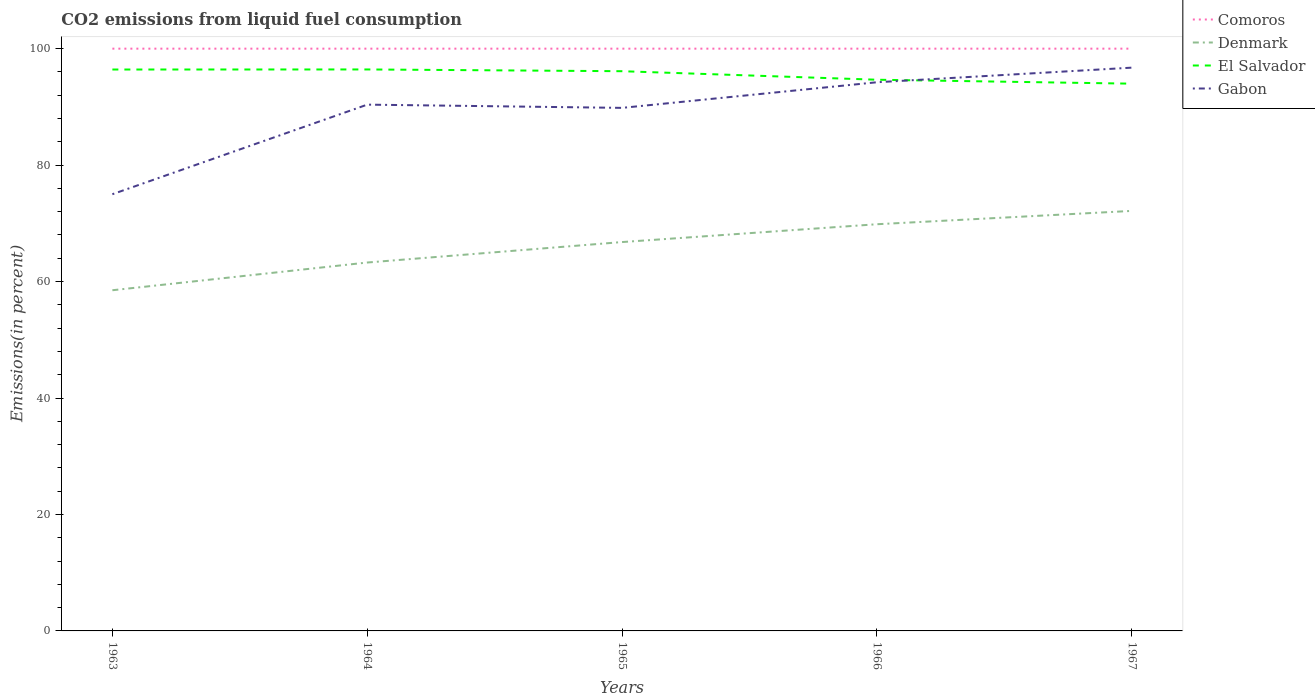How many different coloured lines are there?
Provide a succinct answer. 4. Is the number of lines equal to the number of legend labels?
Your response must be concise. Yes. Across all years, what is the maximum total CO2 emitted in Denmark?
Make the answer very short. 58.51. What is the total total CO2 emitted in El Salvador in the graph?
Offer a very short reply. 0.68. What is the difference between the highest and the second highest total CO2 emitted in El Salvador?
Provide a short and direct response. 2.44. What is the difference between the highest and the lowest total CO2 emitted in Denmark?
Ensure brevity in your answer.  3. Is the total CO2 emitted in Gabon strictly greater than the total CO2 emitted in Comoros over the years?
Your response must be concise. Yes. How many lines are there?
Offer a terse response. 4. How many legend labels are there?
Your response must be concise. 4. How are the legend labels stacked?
Provide a succinct answer. Vertical. What is the title of the graph?
Keep it short and to the point. CO2 emissions from liquid fuel consumption. What is the label or title of the X-axis?
Your response must be concise. Years. What is the label or title of the Y-axis?
Offer a terse response. Emissions(in percent). What is the Emissions(in percent) of Denmark in 1963?
Offer a terse response. 58.51. What is the Emissions(in percent) of El Salvador in 1963?
Your answer should be compact. 96.42. What is the Emissions(in percent) in Gabon in 1963?
Ensure brevity in your answer.  75. What is the Emissions(in percent) in Denmark in 1964?
Provide a short and direct response. 63.27. What is the Emissions(in percent) in El Salvador in 1964?
Offer a terse response. 96.43. What is the Emissions(in percent) of Gabon in 1964?
Make the answer very short. 90.38. What is the Emissions(in percent) of Comoros in 1965?
Make the answer very short. 100. What is the Emissions(in percent) in Denmark in 1965?
Provide a short and direct response. 66.79. What is the Emissions(in percent) of El Salvador in 1965?
Make the answer very short. 96.13. What is the Emissions(in percent) in Gabon in 1965?
Keep it short and to the point. 89.83. What is the Emissions(in percent) in Comoros in 1966?
Your answer should be very brief. 100. What is the Emissions(in percent) in Denmark in 1966?
Offer a very short reply. 69.85. What is the Emissions(in percent) of El Salvador in 1966?
Provide a succinct answer. 94.66. What is the Emissions(in percent) in Gabon in 1966?
Offer a very short reply. 94.23. What is the Emissions(in percent) in Denmark in 1967?
Ensure brevity in your answer.  72.14. What is the Emissions(in percent) in El Salvador in 1967?
Keep it short and to the point. 93.99. What is the Emissions(in percent) in Gabon in 1967?
Your answer should be very brief. 96.74. Across all years, what is the maximum Emissions(in percent) in Denmark?
Provide a succinct answer. 72.14. Across all years, what is the maximum Emissions(in percent) in El Salvador?
Keep it short and to the point. 96.43. Across all years, what is the maximum Emissions(in percent) of Gabon?
Your answer should be very brief. 96.74. Across all years, what is the minimum Emissions(in percent) of Denmark?
Offer a terse response. 58.51. Across all years, what is the minimum Emissions(in percent) of El Salvador?
Keep it short and to the point. 93.99. Across all years, what is the minimum Emissions(in percent) in Gabon?
Ensure brevity in your answer.  75. What is the total Emissions(in percent) of Comoros in the graph?
Your answer should be compact. 500. What is the total Emissions(in percent) in Denmark in the graph?
Provide a short and direct response. 330.55. What is the total Emissions(in percent) in El Salvador in the graph?
Offer a terse response. 477.62. What is the total Emissions(in percent) in Gabon in the graph?
Offer a very short reply. 446.19. What is the difference between the Emissions(in percent) in Denmark in 1963 and that in 1964?
Offer a very short reply. -4.76. What is the difference between the Emissions(in percent) in El Salvador in 1963 and that in 1964?
Provide a succinct answer. -0.01. What is the difference between the Emissions(in percent) in Gabon in 1963 and that in 1964?
Your answer should be compact. -15.38. What is the difference between the Emissions(in percent) of Comoros in 1963 and that in 1965?
Offer a terse response. 0. What is the difference between the Emissions(in percent) in Denmark in 1963 and that in 1965?
Your response must be concise. -8.28. What is the difference between the Emissions(in percent) in El Salvador in 1963 and that in 1965?
Give a very brief answer. 0.29. What is the difference between the Emissions(in percent) in Gabon in 1963 and that in 1965?
Offer a terse response. -14.83. What is the difference between the Emissions(in percent) in Denmark in 1963 and that in 1966?
Your answer should be compact. -11.34. What is the difference between the Emissions(in percent) of El Salvador in 1963 and that in 1966?
Offer a very short reply. 1.75. What is the difference between the Emissions(in percent) of Gabon in 1963 and that in 1966?
Give a very brief answer. -19.23. What is the difference between the Emissions(in percent) of Comoros in 1963 and that in 1967?
Ensure brevity in your answer.  0. What is the difference between the Emissions(in percent) in Denmark in 1963 and that in 1967?
Your answer should be very brief. -13.63. What is the difference between the Emissions(in percent) of El Salvador in 1963 and that in 1967?
Offer a very short reply. 2.43. What is the difference between the Emissions(in percent) in Gabon in 1963 and that in 1967?
Keep it short and to the point. -21.74. What is the difference between the Emissions(in percent) in Comoros in 1964 and that in 1965?
Provide a short and direct response. 0. What is the difference between the Emissions(in percent) of Denmark in 1964 and that in 1965?
Your response must be concise. -3.51. What is the difference between the Emissions(in percent) in El Salvador in 1964 and that in 1965?
Your answer should be very brief. 0.3. What is the difference between the Emissions(in percent) in Gabon in 1964 and that in 1965?
Your answer should be compact. 0.55. What is the difference between the Emissions(in percent) of Denmark in 1964 and that in 1966?
Offer a terse response. -6.58. What is the difference between the Emissions(in percent) in El Salvador in 1964 and that in 1966?
Your response must be concise. 1.77. What is the difference between the Emissions(in percent) in Gabon in 1964 and that in 1966?
Offer a very short reply. -3.85. What is the difference between the Emissions(in percent) of Denmark in 1964 and that in 1967?
Ensure brevity in your answer.  -8.87. What is the difference between the Emissions(in percent) in El Salvador in 1964 and that in 1967?
Your response must be concise. 2.44. What is the difference between the Emissions(in percent) of Gabon in 1964 and that in 1967?
Your answer should be very brief. -6.35. What is the difference between the Emissions(in percent) in Comoros in 1965 and that in 1966?
Your answer should be very brief. 0. What is the difference between the Emissions(in percent) in Denmark in 1965 and that in 1966?
Your answer should be compact. -3.06. What is the difference between the Emissions(in percent) of El Salvador in 1965 and that in 1966?
Offer a very short reply. 1.46. What is the difference between the Emissions(in percent) of Gabon in 1965 and that in 1966?
Offer a terse response. -4.4. What is the difference between the Emissions(in percent) of Denmark in 1965 and that in 1967?
Provide a short and direct response. -5.35. What is the difference between the Emissions(in percent) of El Salvador in 1965 and that in 1967?
Offer a terse response. 2.14. What is the difference between the Emissions(in percent) in Gabon in 1965 and that in 1967?
Provide a succinct answer. -6.91. What is the difference between the Emissions(in percent) in Denmark in 1966 and that in 1967?
Keep it short and to the point. -2.29. What is the difference between the Emissions(in percent) in El Salvador in 1966 and that in 1967?
Offer a terse response. 0.68. What is the difference between the Emissions(in percent) in Gabon in 1966 and that in 1967?
Your answer should be very brief. -2.51. What is the difference between the Emissions(in percent) in Comoros in 1963 and the Emissions(in percent) in Denmark in 1964?
Offer a terse response. 36.73. What is the difference between the Emissions(in percent) of Comoros in 1963 and the Emissions(in percent) of El Salvador in 1964?
Make the answer very short. 3.57. What is the difference between the Emissions(in percent) in Comoros in 1963 and the Emissions(in percent) in Gabon in 1964?
Your answer should be compact. 9.62. What is the difference between the Emissions(in percent) of Denmark in 1963 and the Emissions(in percent) of El Salvador in 1964?
Offer a very short reply. -37.92. What is the difference between the Emissions(in percent) in Denmark in 1963 and the Emissions(in percent) in Gabon in 1964?
Your response must be concise. -31.88. What is the difference between the Emissions(in percent) in El Salvador in 1963 and the Emissions(in percent) in Gabon in 1964?
Give a very brief answer. 6.03. What is the difference between the Emissions(in percent) in Comoros in 1963 and the Emissions(in percent) in Denmark in 1965?
Offer a terse response. 33.21. What is the difference between the Emissions(in percent) in Comoros in 1963 and the Emissions(in percent) in El Salvador in 1965?
Your answer should be very brief. 3.87. What is the difference between the Emissions(in percent) of Comoros in 1963 and the Emissions(in percent) of Gabon in 1965?
Provide a succinct answer. 10.17. What is the difference between the Emissions(in percent) of Denmark in 1963 and the Emissions(in percent) of El Salvador in 1965?
Your answer should be very brief. -37.62. What is the difference between the Emissions(in percent) of Denmark in 1963 and the Emissions(in percent) of Gabon in 1965?
Make the answer very short. -31.32. What is the difference between the Emissions(in percent) in El Salvador in 1963 and the Emissions(in percent) in Gabon in 1965?
Give a very brief answer. 6.59. What is the difference between the Emissions(in percent) of Comoros in 1963 and the Emissions(in percent) of Denmark in 1966?
Your answer should be compact. 30.15. What is the difference between the Emissions(in percent) of Comoros in 1963 and the Emissions(in percent) of El Salvador in 1966?
Ensure brevity in your answer.  5.34. What is the difference between the Emissions(in percent) of Comoros in 1963 and the Emissions(in percent) of Gabon in 1966?
Ensure brevity in your answer.  5.77. What is the difference between the Emissions(in percent) of Denmark in 1963 and the Emissions(in percent) of El Salvador in 1966?
Your response must be concise. -36.15. What is the difference between the Emissions(in percent) in Denmark in 1963 and the Emissions(in percent) in Gabon in 1966?
Provide a succinct answer. -35.72. What is the difference between the Emissions(in percent) of El Salvador in 1963 and the Emissions(in percent) of Gabon in 1966?
Make the answer very short. 2.19. What is the difference between the Emissions(in percent) of Comoros in 1963 and the Emissions(in percent) of Denmark in 1967?
Your answer should be very brief. 27.86. What is the difference between the Emissions(in percent) of Comoros in 1963 and the Emissions(in percent) of El Salvador in 1967?
Provide a succinct answer. 6.01. What is the difference between the Emissions(in percent) of Comoros in 1963 and the Emissions(in percent) of Gabon in 1967?
Offer a terse response. 3.26. What is the difference between the Emissions(in percent) in Denmark in 1963 and the Emissions(in percent) in El Salvador in 1967?
Offer a terse response. -35.48. What is the difference between the Emissions(in percent) of Denmark in 1963 and the Emissions(in percent) of Gabon in 1967?
Your response must be concise. -38.23. What is the difference between the Emissions(in percent) in El Salvador in 1963 and the Emissions(in percent) in Gabon in 1967?
Your response must be concise. -0.32. What is the difference between the Emissions(in percent) in Comoros in 1964 and the Emissions(in percent) in Denmark in 1965?
Your answer should be very brief. 33.21. What is the difference between the Emissions(in percent) in Comoros in 1964 and the Emissions(in percent) in El Salvador in 1965?
Offer a very short reply. 3.87. What is the difference between the Emissions(in percent) of Comoros in 1964 and the Emissions(in percent) of Gabon in 1965?
Your answer should be very brief. 10.17. What is the difference between the Emissions(in percent) in Denmark in 1964 and the Emissions(in percent) in El Salvador in 1965?
Your answer should be very brief. -32.86. What is the difference between the Emissions(in percent) in Denmark in 1964 and the Emissions(in percent) in Gabon in 1965?
Offer a terse response. -26.56. What is the difference between the Emissions(in percent) in El Salvador in 1964 and the Emissions(in percent) in Gabon in 1965?
Ensure brevity in your answer.  6.6. What is the difference between the Emissions(in percent) in Comoros in 1964 and the Emissions(in percent) in Denmark in 1966?
Provide a succinct answer. 30.15. What is the difference between the Emissions(in percent) of Comoros in 1964 and the Emissions(in percent) of El Salvador in 1966?
Your answer should be compact. 5.34. What is the difference between the Emissions(in percent) of Comoros in 1964 and the Emissions(in percent) of Gabon in 1966?
Offer a very short reply. 5.77. What is the difference between the Emissions(in percent) of Denmark in 1964 and the Emissions(in percent) of El Salvador in 1966?
Your answer should be compact. -31.39. What is the difference between the Emissions(in percent) of Denmark in 1964 and the Emissions(in percent) of Gabon in 1966?
Offer a terse response. -30.96. What is the difference between the Emissions(in percent) of El Salvador in 1964 and the Emissions(in percent) of Gabon in 1966?
Give a very brief answer. 2.2. What is the difference between the Emissions(in percent) of Comoros in 1964 and the Emissions(in percent) of Denmark in 1967?
Give a very brief answer. 27.86. What is the difference between the Emissions(in percent) of Comoros in 1964 and the Emissions(in percent) of El Salvador in 1967?
Your answer should be compact. 6.01. What is the difference between the Emissions(in percent) of Comoros in 1964 and the Emissions(in percent) of Gabon in 1967?
Provide a succinct answer. 3.26. What is the difference between the Emissions(in percent) of Denmark in 1964 and the Emissions(in percent) of El Salvador in 1967?
Your answer should be very brief. -30.72. What is the difference between the Emissions(in percent) in Denmark in 1964 and the Emissions(in percent) in Gabon in 1967?
Your response must be concise. -33.47. What is the difference between the Emissions(in percent) of El Salvador in 1964 and the Emissions(in percent) of Gabon in 1967?
Offer a terse response. -0.31. What is the difference between the Emissions(in percent) of Comoros in 1965 and the Emissions(in percent) of Denmark in 1966?
Your response must be concise. 30.15. What is the difference between the Emissions(in percent) of Comoros in 1965 and the Emissions(in percent) of El Salvador in 1966?
Provide a succinct answer. 5.34. What is the difference between the Emissions(in percent) in Comoros in 1965 and the Emissions(in percent) in Gabon in 1966?
Your answer should be very brief. 5.77. What is the difference between the Emissions(in percent) in Denmark in 1965 and the Emissions(in percent) in El Salvador in 1966?
Your response must be concise. -27.88. What is the difference between the Emissions(in percent) of Denmark in 1965 and the Emissions(in percent) of Gabon in 1966?
Offer a terse response. -27.45. What is the difference between the Emissions(in percent) of El Salvador in 1965 and the Emissions(in percent) of Gabon in 1966?
Keep it short and to the point. 1.9. What is the difference between the Emissions(in percent) in Comoros in 1965 and the Emissions(in percent) in Denmark in 1967?
Make the answer very short. 27.86. What is the difference between the Emissions(in percent) in Comoros in 1965 and the Emissions(in percent) in El Salvador in 1967?
Your response must be concise. 6.01. What is the difference between the Emissions(in percent) in Comoros in 1965 and the Emissions(in percent) in Gabon in 1967?
Your answer should be compact. 3.26. What is the difference between the Emissions(in percent) of Denmark in 1965 and the Emissions(in percent) of El Salvador in 1967?
Provide a short and direct response. -27.2. What is the difference between the Emissions(in percent) in Denmark in 1965 and the Emissions(in percent) in Gabon in 1967?
Ensure brevity in your answer.  -29.95. What is the difference between the Emissions(in percent) of El Salvador in 1965 and the Emissions(in percent) of Gabon in 1967?
Your answer should be very brief. -0.61. What is the difference between the Emissions(in percent) of Comoros in 1966 and the Emissions(in percent) of Denmark in 1967?
Ensure brevity in your answer.  27.86. What is the difference between the Emissions(in percent) in Comoros in 1966 and the Emissions(in percent) in El Salvador in 1967?
Your answer should be compact. 6.01. What is the difference between the Emissions(in percent) of Comoros in 1966 and the Emissions(in percent) of Gabon in 1967?
Ensure brevity in your answer.  3.26. What is the difference between the Emissions(in percent) in Denmark in 1966 and the Emissions(in percent) in El Salvador in 1967?
Ensure brevity in your answer.  -24.14. What is the difference between the Emissions(in percent) of Denmark in 1966 and the Emissions(in percent) of Gabon in 1967?
Make the answer very short. -26.89. What is the difference between the Emissions(in percent) in El Salvador in 1966 and the Emissions(in percent) in Gabon in 1967?
Keep it short and to the point. -2.08. What is the average Emissions(in percent) of Comoros per year?
Provide a succinct answer. 100. What is the average Emissions(in percent) of Denmark per year?
Offer a terse response. 66.11. What is the average Emissions(in percent) in El Salvador per year?
Provide a succinct answer. 95.52. What is the average Emissions(in percent) in Gabon per year?
Provide a short and direct response. 89.24. In the year 1963, what is the difference between the Emissions(in percent) in Comoros and Emissions(in percent) in Denmark?
Your response must be concise. 41.49. In the year 1963, what is the difference between the Emissions(in percent) in Comoros and Emissions(in percent) in El Salvador?
Provide a succinct answer. 3.58. In the year 1963, what is the difference between the Emissions(in percent) of Denmark and Emissions(in percent) of El Salvador?
Make the answer very short. -37.91. In the year 1963, what is the difference between the Emissions(in percent) of Denmark and Emissions(in percent) of Gabon?
Your answer should be compact. -16.49. In the year 1963, what is the difference between the Emissions(in percent) of El Salvador and Emissions(in percent) of Gabon?
Give a very brief answer. 21.42. In the year 1964, what is the difference between the Emissions(in percent) of Comoros and Emissions(in percent) of Denmark?
Keep it short and to the point. 36.73. In the year 1964, what is the difference between the Emissions(in percent) of Comoros and Emissions(in percent) of El Salvador?
Offer a very short reply. 3.57. In the year 1964, what is the difference between the Emissions(in percent) of Comoros and Emissions(in percent) of Gabon?
Provide a short and direct response. 9.62. In the year 1964, what is the difference between the Emissions(in percent) of Denmark and Emissions(in percent) of El Salvador?
Provide a short and direct response. -33.16. In the year 1964, what is the difference between the Emissions(in percent) in Denmark and Emissions(in percent) in Gabon?
Ensure brevity in your answer.  -27.11. In the year 1964, what is the difference between the Emissions(in percent) in El Salvador and Emissions(in percent) in Gabon?
Give a very brief answer. 6.04. In the year 1965, what is the difference between the Emissions(in percent) in Comoros and Emissions(in percent) in Denmark?
Offer a very short reply. 33.21. In the year 1965, what is the difference between the Emissions(in percent) in Comoros and Emissions(in percent) in El Salvador?
Make the answer very short. 3.87. In the year 1965, what is the difference between the Emissions(in percent) of Comoros and Emissions(in percent) of Gabon?
Provide a short and direct response. 10.17. In the year 1965, what is the difference between the Emissions(in percent) in Denmark and Emissions(in percent) in El Salvador?
Your response must be concise. -29.34. In the year 1965, what is the difference between the Emissions(in percent) of Denmark and Emissions(in percent) of Gabon?
Your response must be concise. -23.05. In the year 1965, what is the difference between the Emissions(in percent) in El Salvador and Emissions(in percent) in Gabon?
Give a very brief answer. 6.3. In the year 1966, what is the difference between the Emissions(in percent) in Comoros and Emissions(in percent) in Denmark?
Your answer should be compact. 30.15. In the year 1966, what is the difference between the Emissions(in percent) of Comoros and Emissions(in percent) of El Salvador?
Ensure brevity in your answer.  5.34. In the year 1966, what is the difference between the Emissions(in percent) of Comoros and Emissions(in percent) of Gabon?
Give a very brief answer. 5.77. In the year 1966, what is the difference between the Emissions(in percent) in Denmark and Emissions(in percent) in El Salvador?
Your response must be concise. -24.82. In the year 1966, what is the difference between the Emissions(in percent) of Denmark and Emissions(in percent) of Gabon?
Provide a succinct answer. -24.38. In the year 1966, what is the difference between the Emissions(in percent) in El Salvador and Emissions(in percent) in Gabon?
Keep it short and to the point. 0.43. In the year 1967, what is the difference between the Emissions(in percent) in Comoros and Emissions(in percent) in Denmark?
Keep it short and to the point. 27.86. In the year 1967, what is the difference between the Emissions(in percent) in Comoros and Emissions(in percent) in El Salvador?
Your answer should be very brief. 6.01. In the year 1967, what is the difference between the Emissions(in percent) in Comoros and Emissions(in percent) in Gabon?
Provide a short and direct response. 3.26. In the year 1967, what is the difference between the Emissions(in percent) in Denmark and Emissions(in percent) in El Salvador?
Your response must be concise. -21.85. In the year 1967, what is the difference between the Emissions(in percent) of Denmark and Emissions(in percent) of Gabon?
Your answer should be compact. -24.6. In the year 1967, what is the difference between the Emissions(in percent) in El Salvador and Emissions(in percent) in Gabon?
Provide a succinct answer. -2.75. What is the ratio of the Emissions(in percent) of Comoros in 1963 to that in 1964?
Offer a very short reply. 1. What is the ratio of the Emissions(in percent) of Denmark in 1963 to that in 1964?
Make the answer very short. 0.92. What is the ratio of the Emissions(in percent) in Gabon in 1963 to that in 1964?
Ensure brevity in your answer.  0.83. What is the ratio of the Emissions(in percent) in Denmark in 1963 to that in 1965?
Give a very brief answer. 0.88. What is the ratio of the Emissions(in percent) in Gabon in 1963 to that in 1965?
Keep it short and to the point. 0.83. What is the ratio of the Emissions(in percent) of Denmark in 1963 to that in 1966?
Give a very brief answer. 0.84. What is the ratio of the Emissions(in percent) in El Salvador in 1963 to that in 1966?
Keep it short and to the point. 1.02. What is the ratio of the Emissions(in percent) of Gabon in 1963 to that in 1966?
Your response must be concise. 0.8. What is the ratio of the Emissions(in percent) of Comoros in 1963 to that in 1967?
Ensure brevity in your answer.  1. What is the ratio of the Emissions(in percent) in Denmark in 1963 to that in 1967?
Your answer should be compact. 0.81. What is the ratio of the Emissions(in percent) in El Salvador in 1963 to that in 1967?
Keep it short and to the point. 1.03. What is the ratio of the Emissions(in percent) of Gabon in 1963 to that in 1967?
Keep it short and to the point. 0.78. What is the ratio of the Emissions(in percent) of Denmark in 1964 to that in 1965?
Ensure brevity in your answer.  0.95. What is the ratio of the Emissions(in percent) in El Salvador in 1964 to that in 1965?
Your response must be concise. 1. What is the ratio of the Emissions(in percent) of Comoros in 1964 to that in 1966?
Ensure brevity in your answer.  1. What is the ratio of the Emissions(in percent) in Denmark in 1964 to that in 1966?
Provide a succinct answer. 0.91. What is the ratio of the Emissions(in percent) of El Salvador in 1964 to that in 1966?
Your answer should be compact. 1.02. What is the ratio of the Emissions(in percent) of Gabon in 1964 to that in 1966?
Your response must be concise. 0.96. What is the ratio of the Emissions(in percent) in Comoros in 1964 to that in 1967?
Keep it short and to the point. 1. What is the ratio of the Emissions(in percent) of Denmark in 1964 to that in 1967?
Offer a very short reply. 0.88. What is the ratio of the Emissions(in percent) in Gabon in 1964 to that in 1967?
Your response must be concise. 0.93. What is the ratio of the Emissions(in percent) in Denmark in 1965 to that in 1966?
Provide a short and direct response. 0.96. What is the ratio of the Emissions(in percent) of El Salvador in 1965 to that in 1966?
Offer a terse response. 1.02. What is the ratio of the Emissions(in percent) of Gabon in 1965 to that in 1966?
Keep it short and to the point. 0.95. What is the ratio of the Emissions(in percent) of Comoros in 1965 to that in 1967?
Make the answer very short. 1. What is the ratio of the Emissions(in percent) of Denmark in 1965 to that in 1967?
Give a very brief answer. 0.93. What is the ratio of the Emissions(in percent) of El Salvador in 1965 to that in 1967?
Give a very brief answer. 1.02. What is the ratio of the Emissions(in percent) in Comoros in 1966 to that in 1967?
Your response must be concise. 1. What is the ratio of the Emissions(in percent) in Denmark in 1966 to that in 1967?
Ensure brevity in your answer.  0.97. What is the ratio of the Emissions(in percent) in Gabon in 1966 to that in 1967?
Offer a very short reply. 0.97. What is the difference between the highest and the second highest Emissions(in percent) of Denmark?
Your answer should be compact. 2.29. What is the difference between the highest and the second highest Emissions(in percent) of El Salvador?
Provide a succinct answer. 0.01. What is the difference between the highest and the second highest Emissions(in percent) in Gabon?
Your response must be concise. 2.51. What is the difference between the highest and the lowest Emissions(in percent) of Comoros?
Offer a very short reply. 0. What is the difference between the highest and the lowest Emissions(in percent) of Denmark?
Provide a short and direct response. 13.63. What is the difference between the highest and the lowest Emissions(in percent) in El Salvador?
Make the answer very short. 2.44. What is the difference between the highest and the lowest Emissions(in percent) in Gabon?
Give a very brief answer. 21.74. 